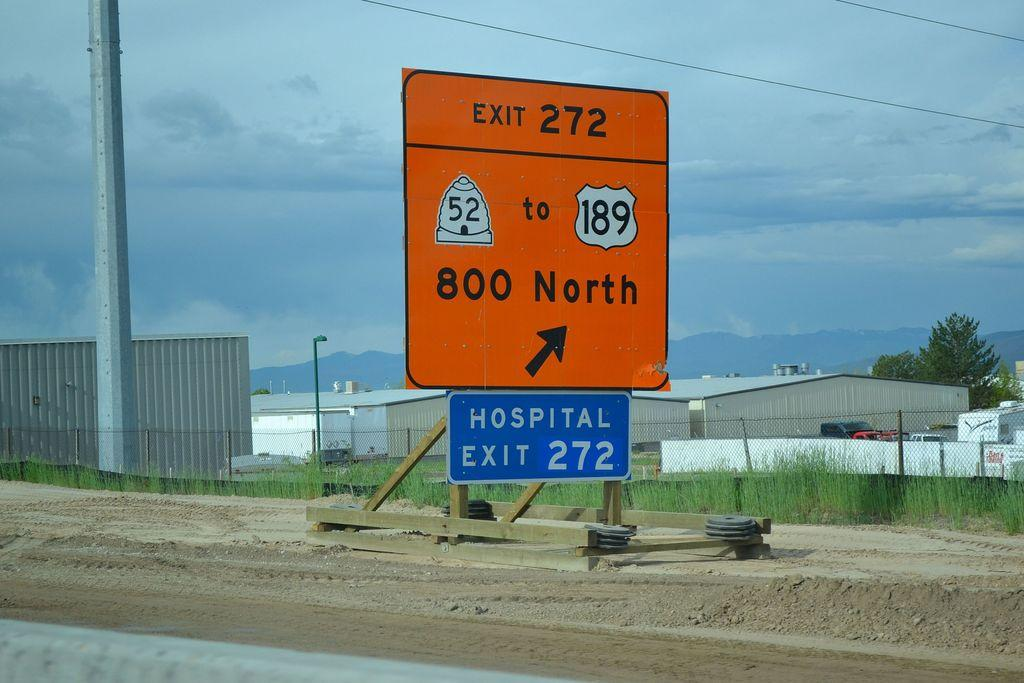Provide a one-sentence caption for the provided image. Orange exit sign for exit 272 where there is a hospital too. 